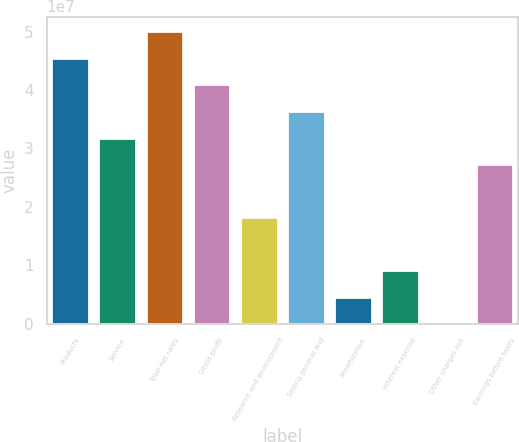Convert chart to OTSL. <chart><loc_0><loc_0><loc_500><loc_500><bar_chart><fcel>Products<fcel>Service<fcel>Total net sales<fcel>Gross profit<fcel>Research and development<fcel>Selling general and<fcel>Amortization<fcel>Interest expense<fcel>Other charges net<fcel>Earnings before taxes<nl><fcel>4.55088e+07<fcel>3.18576e+07<fcel>5.00593e+07<fcel>4.09584e+07<fcel>1.82063e+07<fcel>3.6408e+07<fcel>4.55499e+06<fcel>9.10542e+06<fcel>4563<fcel>2.73071e+07<nl></chart> 